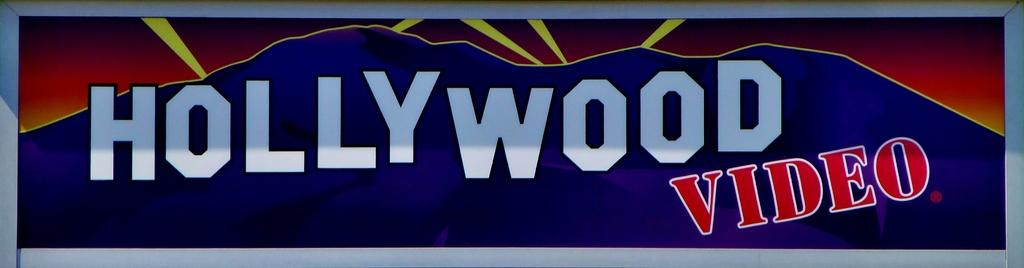Provide a one-sentence caption for the provided image. A Hollywood Video store sign with blue and red coloring. 